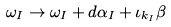Convert formula to latex. <formula><loc_0><loc_0><loc_500><loc_500>\omega _ { I } \to \omega _ { I } + d \alpha _ { I } + \iota _ { k _ { I } } \beta</formula> 